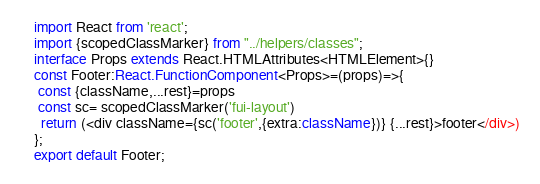Convert code to text. <code><loc_0><loc_0><loc_500><loc_500><_TypeScript_>import React from 'react';
import {scopedClassMarker} from "../helpers/classes";
interface Props extends React.HTMLAttributes<HTMLElement>{}
const Footer:React.FunctionComponent<Props>=(props)=>{
 const {className,...rest}=props
 const sc= scopedClassMarker('fui-layout')
  return (<div className={sc('footer',{extra:className})} {...rest}>footer</div>)
};
export default Footer;</code> 